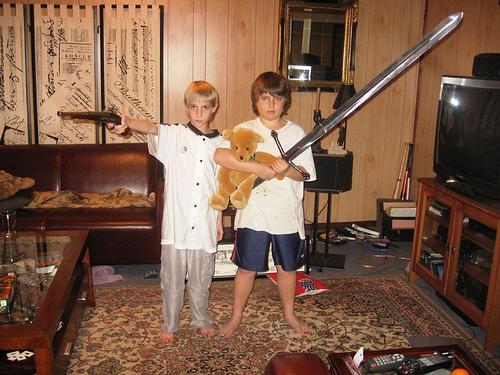Are these objects appropriate for children?
Concise answer only. No. How many bats are there?
Short answer required. 0. Does the boy on left have a shirt on?
Keep it brief. Yes. What sort of items are on the tables?
Concise answer only. Remotes. Do the children have shoes on?
Short answer required. No. What are the people doing?
Concise answer only. Posing. 